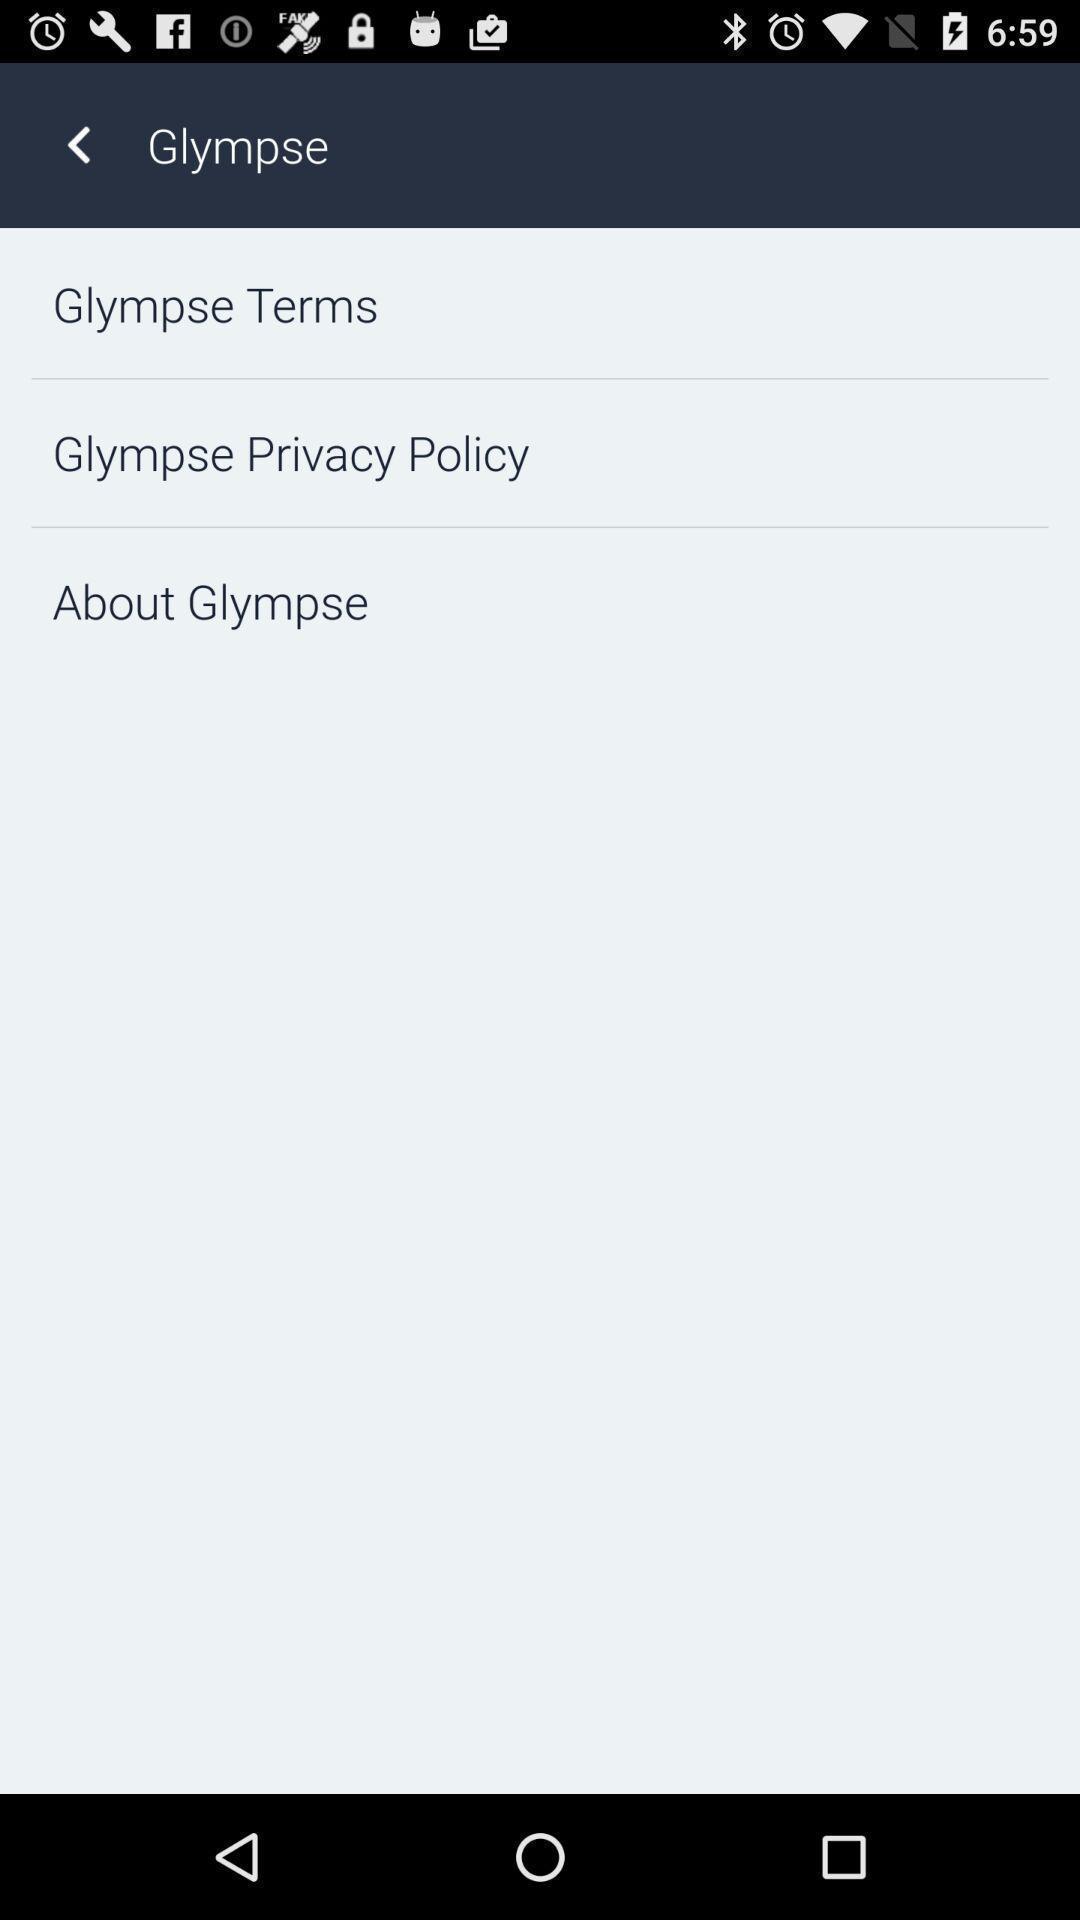Provide a detailed account of this screenshot. Page displaying with various options in application. 